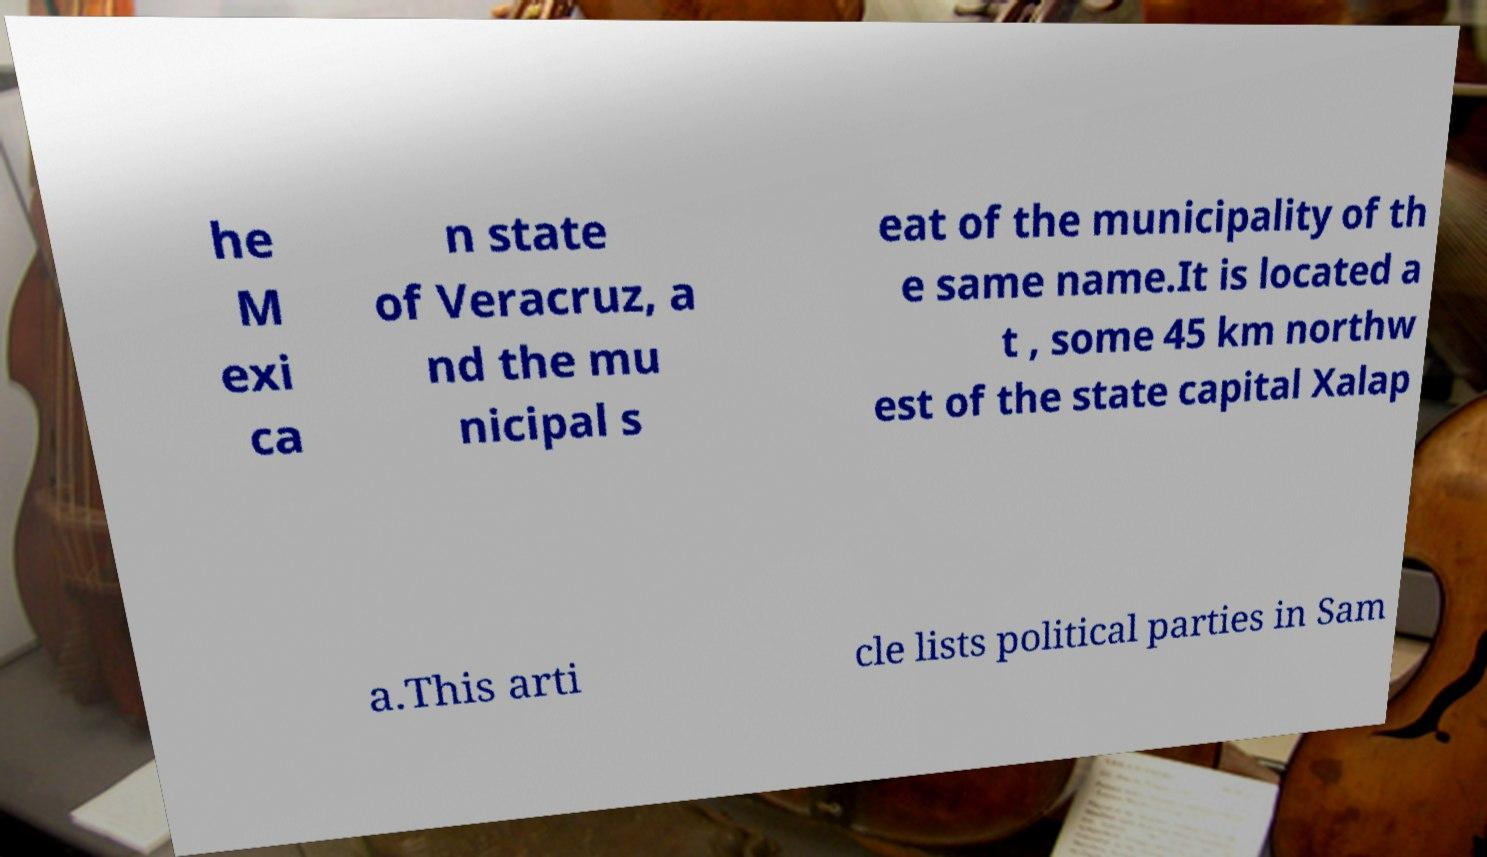What messages or text are displayed in this image? I need them in a readable, typed format. he M exi ca n state of Veracruz, a nd the mu nicipal s eat of the municipality of th e same name.It is located a t , some 45 km northw est of the state capital Xalap a.This arti cle lists political parties in Sam 